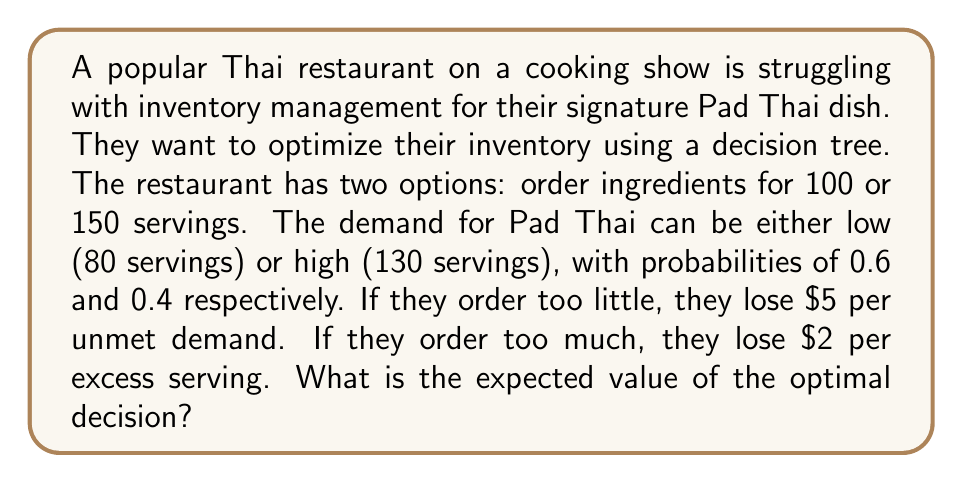Give your solution to this math problem. Let's approach this problem step-by-step using a decision tree:

1. First, let's calculate the outcomes for each scenario:

   a) Order 100, Demand 80:
      Profit = 100 * 0 - 0 * 5 = $0
   
   b) Order 100, Demand 130:
      Profit = 100 * 0 - 30 * 5 = -$150
   
   c) Order 150, Demand 80:
      Profit = 80 * 0 - 70 * 2 = -$140
   
   d) Order 150, Demand 130:
      Profit = 130 * 0 - 20 * 2 = -$40

2. Now, let's calculate the expected value for each decision:

   Order 100:
   $$EV_{100} = 0 * 0.6 + (-150) * 0.4 = -$60$$

   Order 150:
   $$EV_{150} = (-140) * 0.6 + (-40) * 0.4 = -$100$$

3. The optimal decision is the one with the higher (less negative) expected value, which is to order 100 servings.

4. Therefore, the expected value of the optimal decision is -$60.
Answer: The expected value of the optimal decision is -$60. 